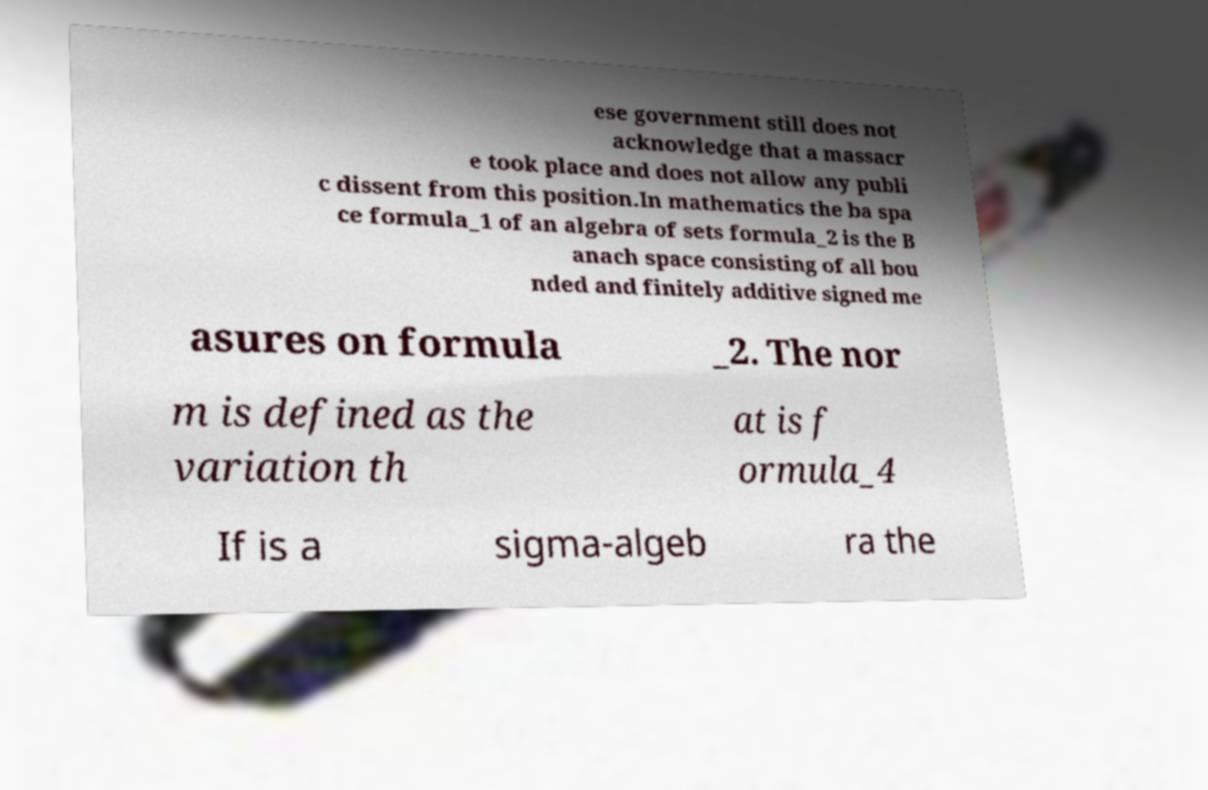Can you read and provide the text displayed in the image?This photo seems to have some interesting text. Can you extract and type it out for me? ese government still does not acknowledge that a massacr e took place and does not allow any publi c dissent from this position.In mathematics the ba spa ce formula_1 of an algebra of sets formula_2 is the B anach space consisting of all bou nded and finitely additive signed me asures on formula _2. The nor m is defined as the variation th at is f ormula_4 If is a sigma-algeb ra the 